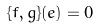<formula> <loc_0><loc_0><loc_500><loc_500>\{ f , g \} ( e ) = 0</formula> 